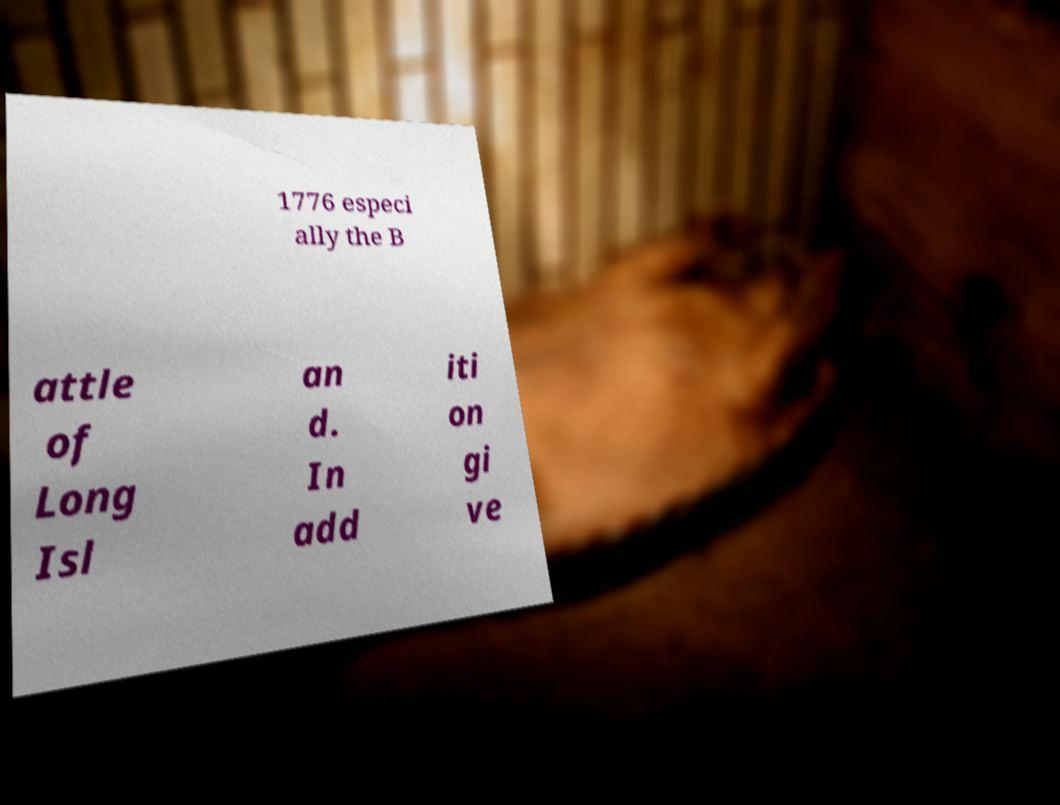I need the written content from this picture converted into text. Can you do that? 1776 especi ally the B attle of Long Isl an d. In add iti on gi ve 